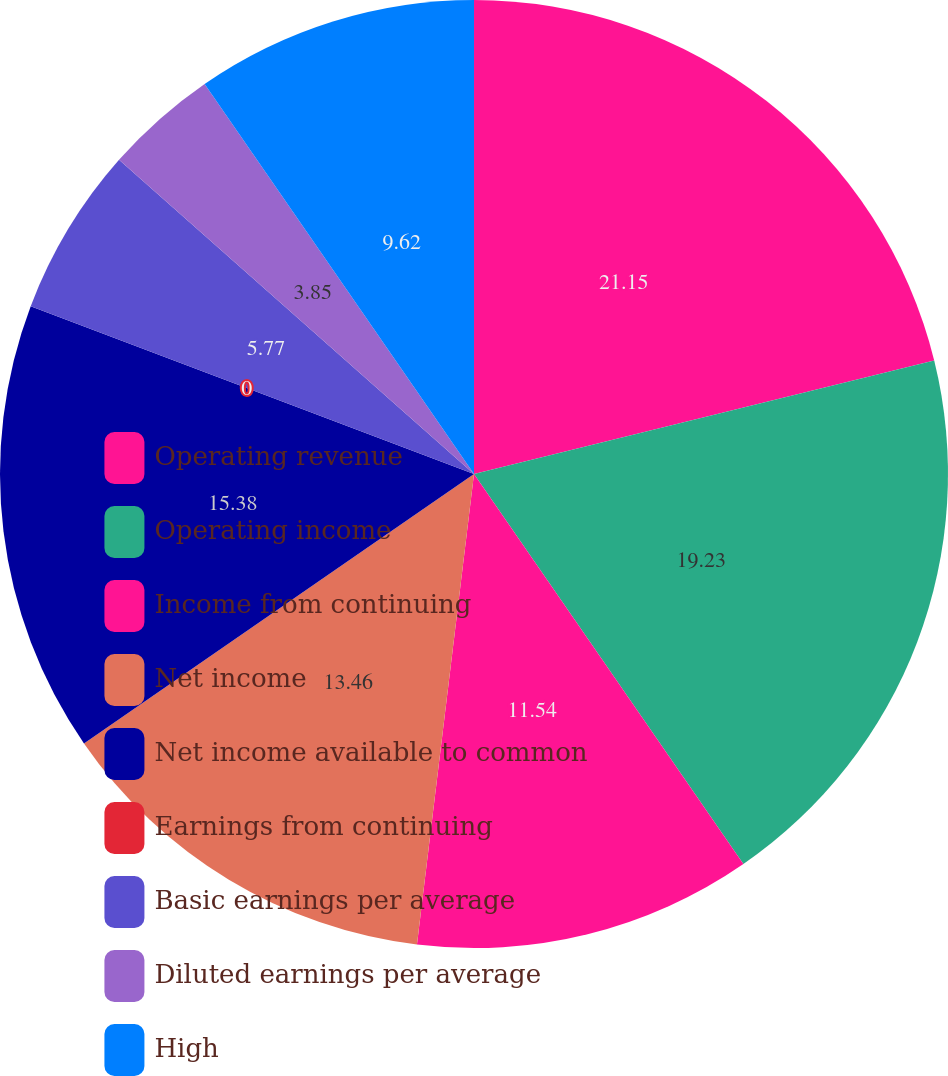Convert chart. <chart><loc_0><loc_0><loc_500><loc_500><pie_chart><fcel>Operating revenue<fcel>Operating income<fcel>Income from continuing<fcel>Net income<fcel>Net income available to common<fcel>Earnings from continuing<fcel>Basic earnings per average<fcel>Diluted earnings per average<fcel>High<nl><fcel>21.15%<fcel>19.23%<fcel>11.54%<fcel>13.46%<fcel>15.38%<fcel>0.0%<fcel>5.77%<fcel>3.85%<fcel>9.62%<nl></chart> 